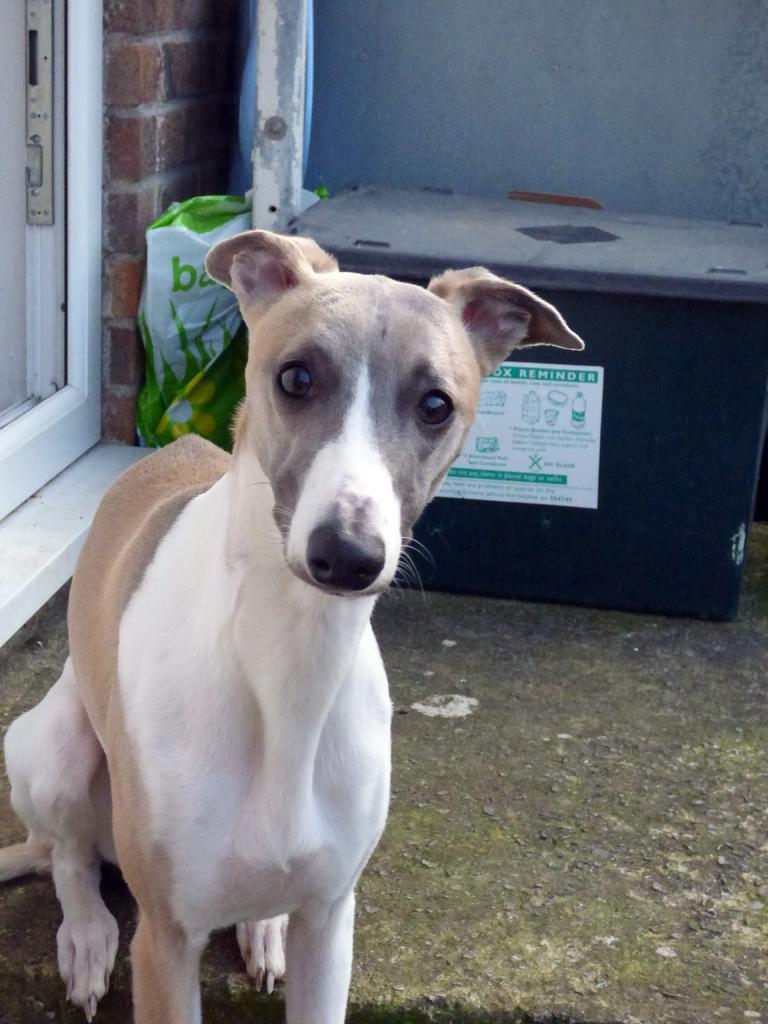Describe this image in one or two sentences. In this picture we can see a dog sitting in the front, on the left side there is a door, we can see a wall in the background, there is a box and a bag in the middle. 